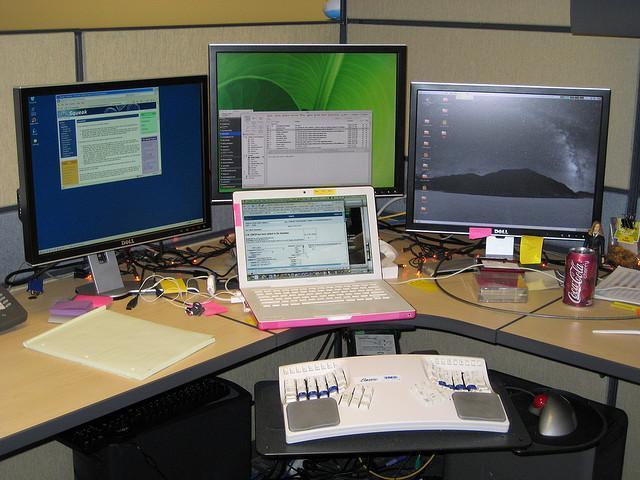How many screens do you see?
Give a very brief answer. 4. How many computers?
Give a very brief answer. 4. How many tvs are in the photo?
Give a very brief answer. 3. How many keyboards are there?
Give a very brief answer. 2. 